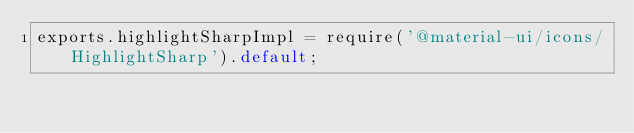<code> <loc_0><loc_0><loc_500><loc_500><_JavaScript_>exports.highlightSharpImpl = require('@material-ui/icons/HighlightSharp').default;
</code> 